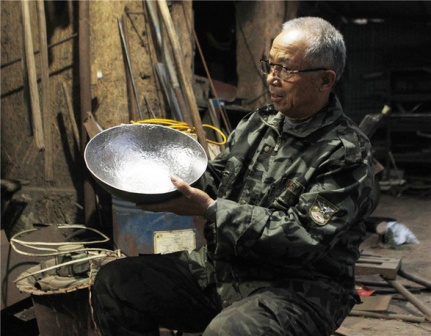Imagine if the tools in the workshop came to life. What would a conversation between them sound like? In the animated world of this workshop, each tool might have a unique personality and voice. The old saw could boast about the countless pieces of wood it has sliced through with precision, while the younger wrench might brag about fixing the latest machinery. The hammers would share tales of nailing down tricky pieces and the wise old tape measure might reminisce about measuring great projects with exactitude. Together, they would exchange stories of the many projects they've collectively contributed to, each proud of their role in the creation process. What might be the most memorable project completed in this workshop? The most memorable project could be an intricately designed piece of furniture, such as a beautifully carved wooden chair or a detailed metal sculpture. The pride in the tools' conversation might be evident when recalling the meticulous measurements, the perfect cuts, and the detailed finishing touches. This project would stand out for its beauty, functionality, and the craftsmanship it exemplifies, symbolizing the culmination of skills honed over years of dedication. If the materials in the workshop decided to stage a play, what would be the theme and characters? The play would be a dramatized epic of creation, featuring characters such as the noble Wood, the steadfast Metal, and the versatile Plastic. The Hammer would be the heroic protagonist, aiding the materials in transforming into their destined shapes. The villain, Rust, would constantly threaten to weaken and corrode the creations, but with the concerted effort of all tools and materials, they would overcome the adversities, highlighting themes of resilience, collaboration, and creativity. It would be a story celebrating the cyclical nature of creation and the timeless legacy of craftsmanship. 